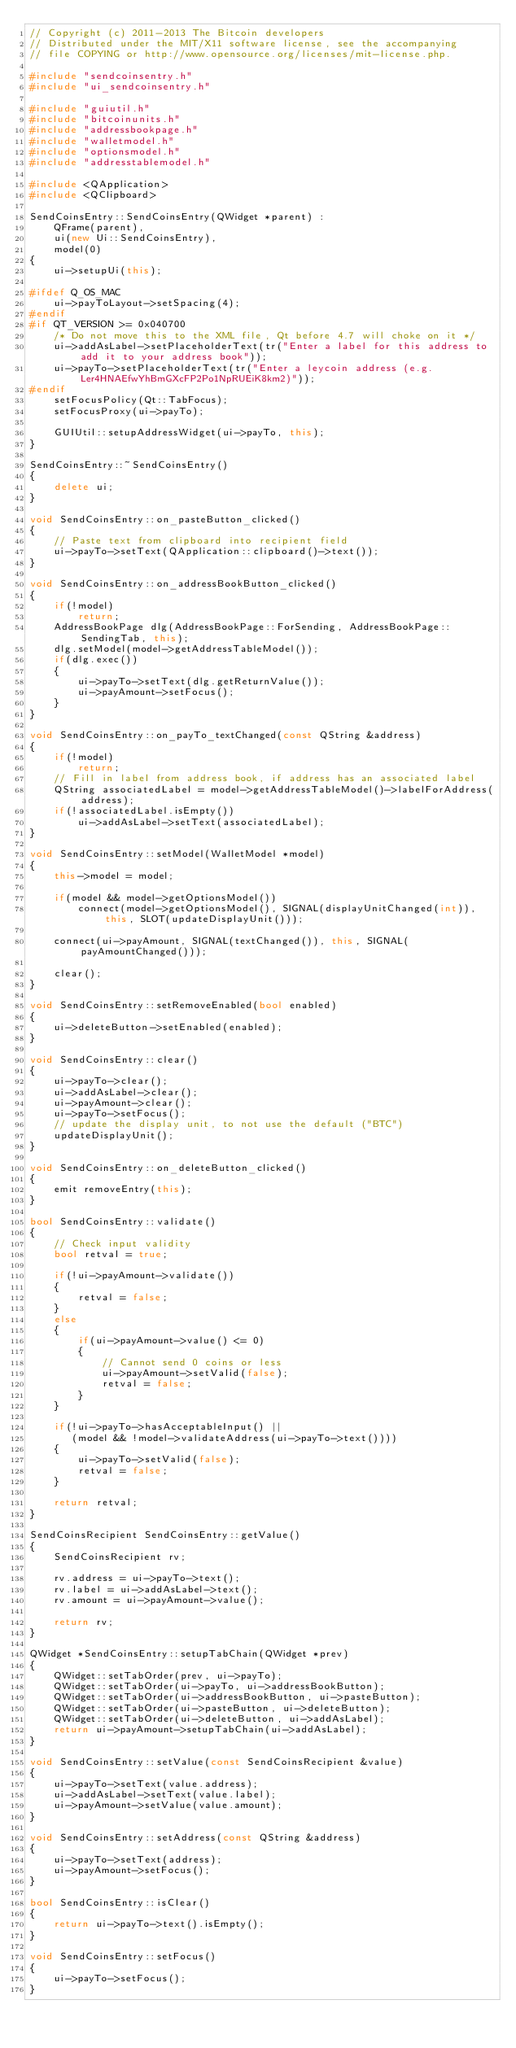<code> <loc_0><loc_0><loc_500><loc_500><_C++_>// Copyright (c) 2011-2013 The Bitcoin developers
// Distributed under the MIT/X11 software license, see the accompanying
// file COPYING or http://www.opensource.org/licenses/mit-license.php.

#include "sendcoinsentry.h"
#include "ui_sendcoinsentry.h"

#include "guiutil.h"
#include "bitcoinunits.h"
#include "addressbookpage.h"
#include "walletmodel.h"
#include "optionsmodel.h"
#include "addresstablemodel.h"

#include <QApplication>
#include <QClipboard>

SendCoinsEntry::SendCoinsEntry(QWidget *parent) :
    QFrame(parent),
    ui(new Ui::SendCoinsEntry),
    model(0)
{
    ui->setupUi(this);

#ifdef Q_OS_MAC
    ui->payToLayout->setSpacing(4);
#endif
#if QT_VERSION >= 0x040700
    /* Do not move this to the XML file, Qt before 4.7 will choke on it */
    ui->addAsLabel->setPlaceholderText(tr("Enter a label for this address to add it to your address book"));
    ui->payTo->setPlaceholderText(tr("Enter a leycoin address (e.g. Ler4HNAEfwYhBmGXcFP2Po1NpRUEiK8km2)"));
#endif
    setFocusPolicy(Qt::TabFocus);
    setFocusProxy(ui->payTo);

    GUIUtil::setupAddressWidget(ui->payTo, this);
}

SendCoinsEntry::~SendCoinsEntry()
{
    delete ui;
}

void SendCoinsEntry::on_pasteButton_clicked()
{
    // Paste text from clipboard into recipient field
    ui->payTo->setText(QApplication::clipboard()->text());
}

void SendCoinsEntry::on_addressBookButton_clicked()
{
    if(!model)
        return;
    AddressBookPage dlg(AddressBookPage::ForSending, AddressBookPage::SendingTab, this);
    dlg.setModel(model->getAddressTableModel());
    if(dlg.exec())
    {
        ui->payTo->setText(dlg.getReturnValue());
        ui->payAmount->setFocus();
    }
}

void SendCoinsEntry::on_payTo_textChanged(const QString &address)
{
    if(!model)
        return;
    // Fill in label from address book, if address has an associated label
    QString associatedLabel = model->getAddressTableModel()->labelForAddress(address);
    if(!associatedLabel.isEmpty())
        ui->addAsLabel->setText(associatedLabel);
}

void SendCoinsEntry::setModel(WalletModel *model)
{
    this->model = model;

    if(model && model->getOptionsModel())
        connect(model->getOptionsModel(), SIGNAL(displayUnitChanged(int)), this, SLOT(updateDisplayUnit()));

    connect(ui->payAmount, SIGNAL(textChanged()), this, SIGNAL(payAmountChanged()));

    clear();
}

void SendCoinsEntry::setRemoveEnabled(bool enabled)
{
    ui->deleteButton->setEnabled(enabled);
}

void SendCoinsEntry::clear()
{
    ui->payTo->clear();
    ui->addAsLabel->clear();
    ui->payAmount->clear();
    ui->payTo->setFocus();
    // update the display unit, to not use the default ("BTC")
    updateDisplayUnit();
}

void SendCoinsEntry::on_deleteButton_clicked()
{
    emit removeEntry(this);
}

bool SendCoinsEntry::validate()
{
    // Check input validity
    bool retval = true;

    if(!ui->payAmount->validate())
    {
        retval = false;
    }
    else
    {
        if(ui->payAmount->value() <= 0)
        {
            // Cannot send 0 coins or less
            ui->payAmount->setValid(false);
            retval = false;
        }
    }

    if(!ui->payTo->hasAcceptableInput() ||
       (model && !model->validateAddress(ui->payTo->text())))
    {
        ui->payTo->setValid(false);
        retval = false;
    }

    return retval;
}

SendCoinsRecipient SendCoinsEntry::getValue()
{
    SendCoinsRecipient rv;

    rv.address = ui->payTo->text();
    rv.label = ui->addAsLabel->text();
    rv.amount = ui->payAmount->value();

    return rv;
}

QWidget *SendCoinsEntry::setupTabChain(QWidget *prev)
{
    QWidget::setTabOrder(prev, ui->payTo);
    QWidget::setTabOrder(ui->payTo, ui->addressBookButton);
    QWidget::setTabOrder(ui->addressBookButton, ui->pasteButton);
    QWidget::setTabOrder(ui->pasteButton, ui->deleteButton);
    QWidget::setTabOrder(ui->deleteButton, ui->addAsLabel);
    return ui->payAmount->setupTabChain(ui->addAsLabel);
}

void SendCoinsEntry::setValue(const SendCoinsRecipient &value)
{
    ui->payTo->setText(value.address);
    ui->addAsLabel->setText(value.label);
    ui->payAmount->setValue(value.amount);
}

void SendCoinsEntry::setAddress(const QString &address)
{
    ui->payTo->setText(address);
    ui->payAmount->setFocus();
}

bool SendCoinsEntry::isClear()
{
    return ui->payTo->text().isEmpty();
}

void SendCoinsEntry::setFocus()
{
    ui->payTo->setFocus();
}
</code> 